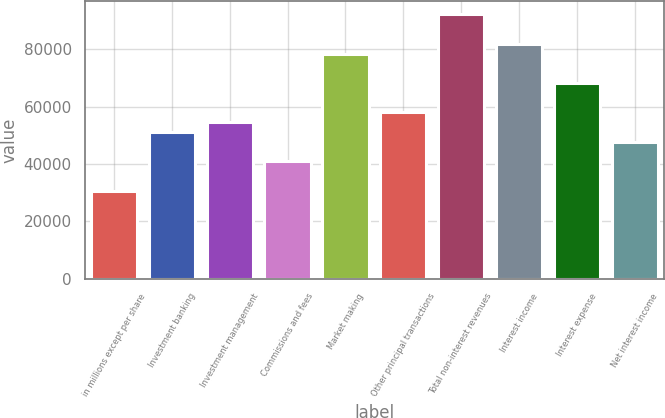Convert chart. <chart><loc_0><loc_0><loc_500><loc_500><bar_chart><fcel>in millions except per share<fcel>Investment banking<fcel>Investment management<fcel>Commissions and fees<fcel>Market making<fcel>Other principal transactions<fcel>Total non-interest revenues<fcel>Interest income<fcel>Interest expense<fcel>Net interest income<nl><fcel>30748.1<fcel>51237.5<fcel>54652.4<fcel>40992.8<fcel>78556.6<fcel>58067.3<fcel>92216.2<fcel>81971.5<fcel>68311.9<fcel>47822.6<nl></chart> 